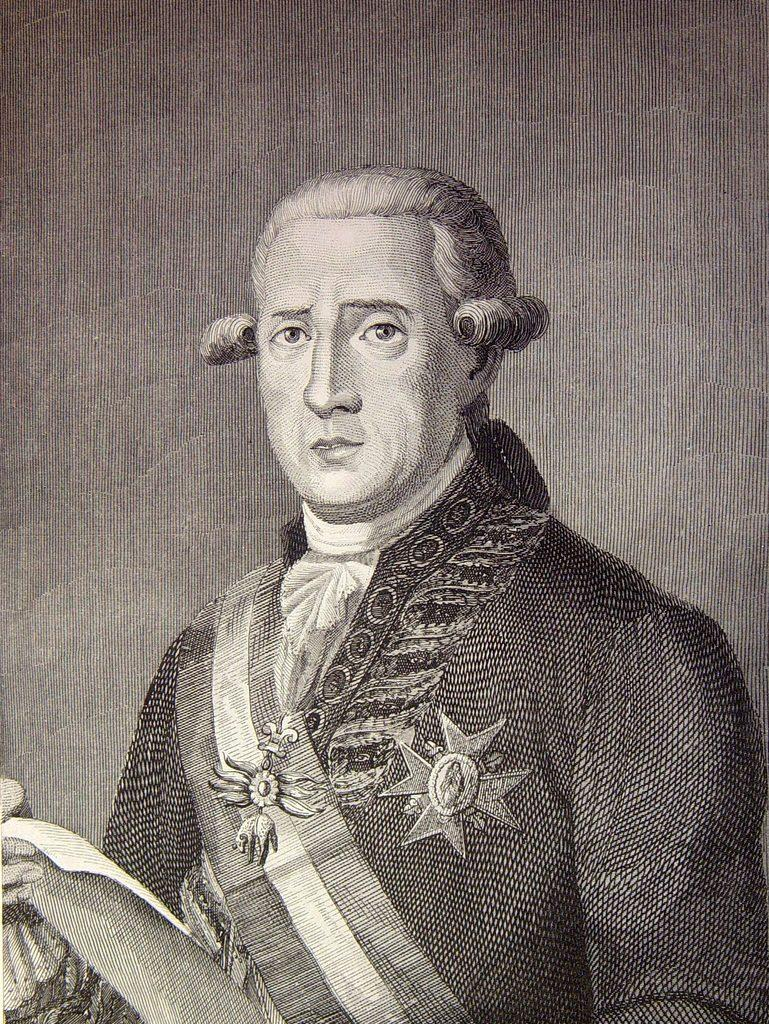What is the main subject of the image? There is a painting in the image. What is depicted in the painting? The painting depicts a person. What is the person in the painting holding? The person in the painting is holding a paper. What type of argument is the person in the painting having with the basket? There is no basket present in the image, and therefore no argument can be observed. 